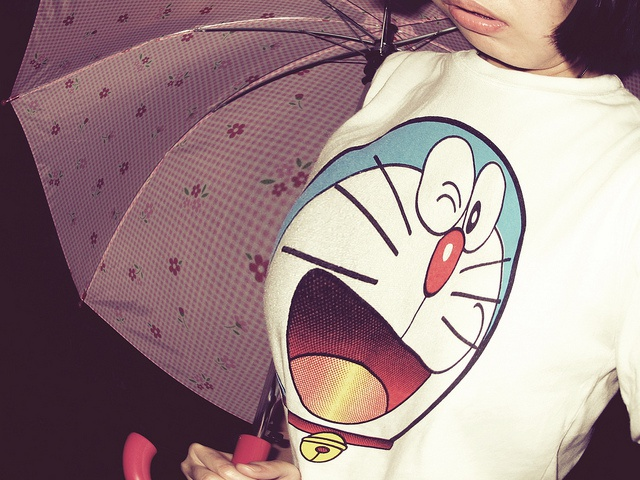Describe the objects in this image and their specific colors. I can see people in black, ivory, and tan tones and umbrella in black, gray, and purple tones in this image. 